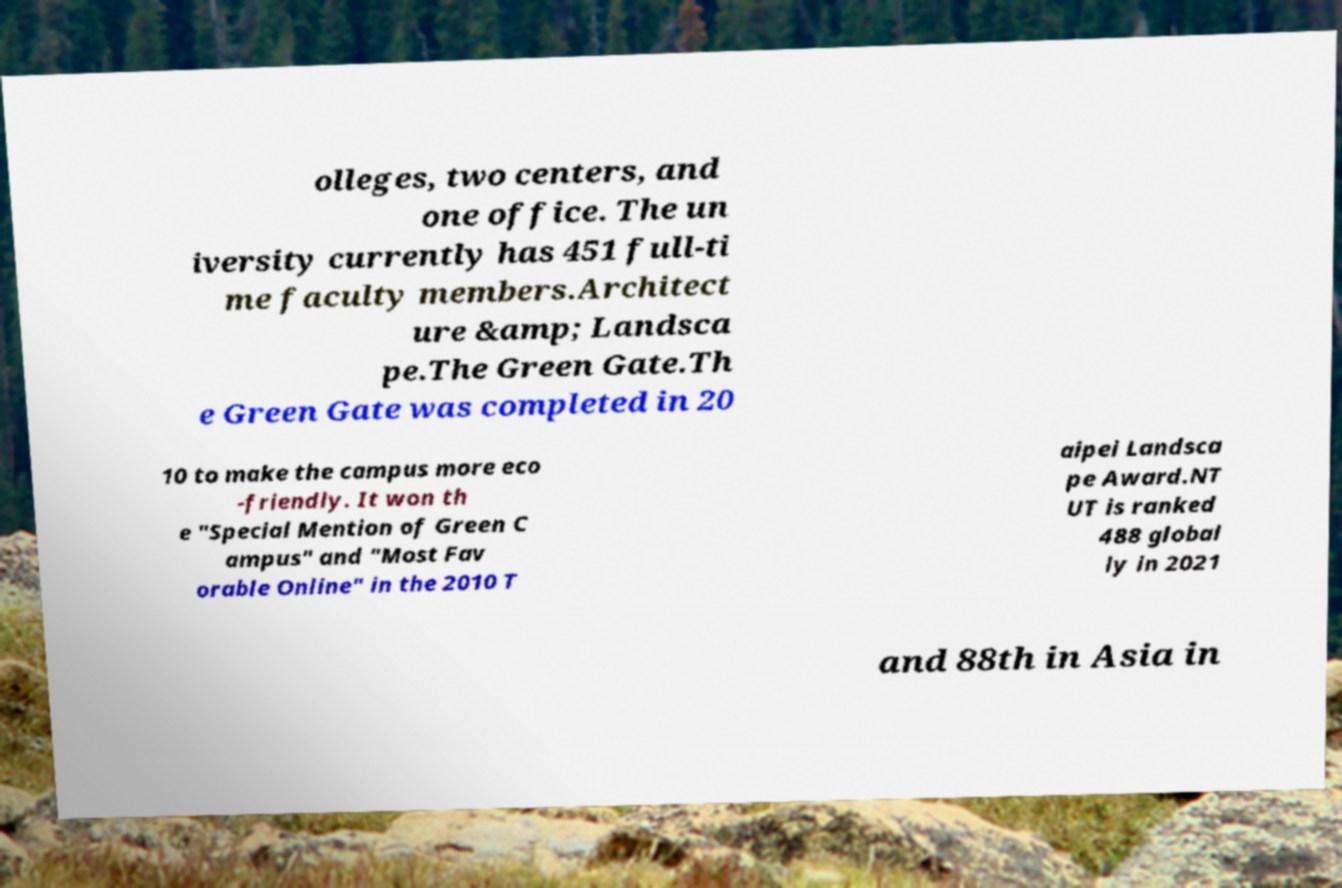Please read and relay the text visible in this image. What does it say? olleges, two centers, and one office. The un iversity currently has 451 full-ti me faculty members.Architect ure &amp; Landsca pe.The Green Gate.Th e Green Gate was completed in 20 10 to make the campus more eco -friendly. It won th e "Special Mention of Green C ampus" and "Most Fav orable Online" in the 2010 T aipei Landsca pe Award.NT UT is ranked 488 global ly in 2021 and 88th in Asia in 